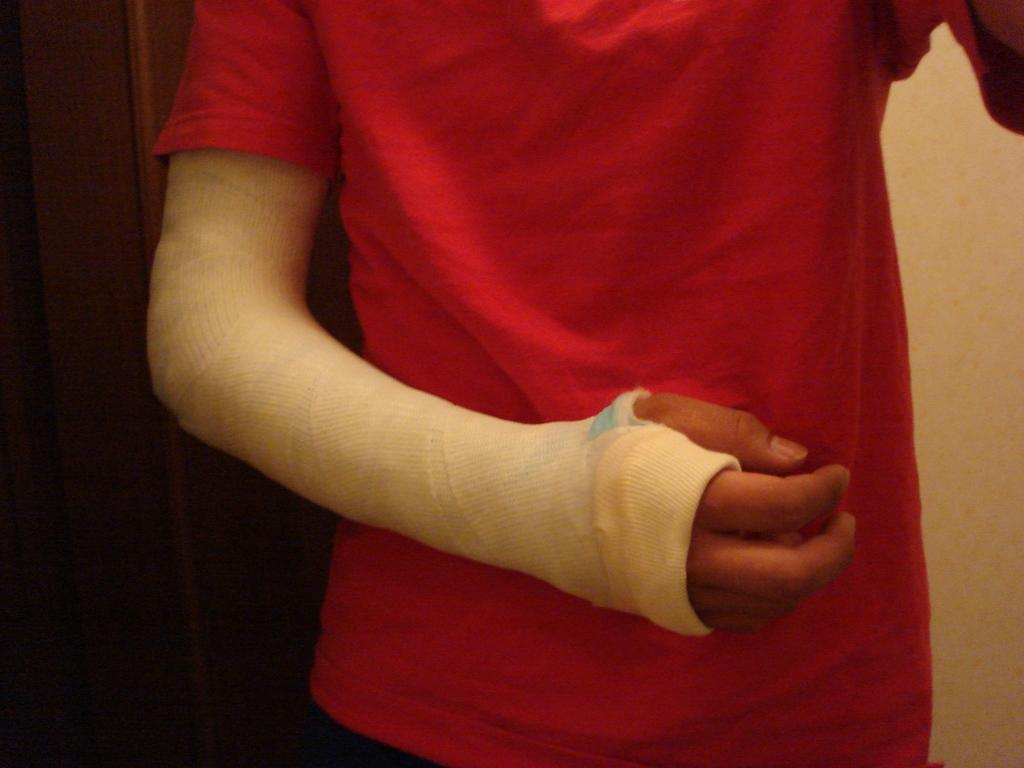What is the condition of the person in the image? The person in the image has a bandage. What color is the t-shirt worn by the person? The person is wearing a red color t-shirt. What can be seen to the right of the person? There is a wall to the right of the person. What can be seen to the left of the person? There is a door to the left of the person. What type of tent can be seen in the image? There is no tent present in the image. How does the person roll the bandage in the image? The person is not rolling the bandage in the image; it is already applied. 